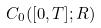Convert formula to latex. <formula><loc_0><loc_0><loc_500><loc_500>C _ { 0 } ( [ 0 , T ] ; R )</formula> 